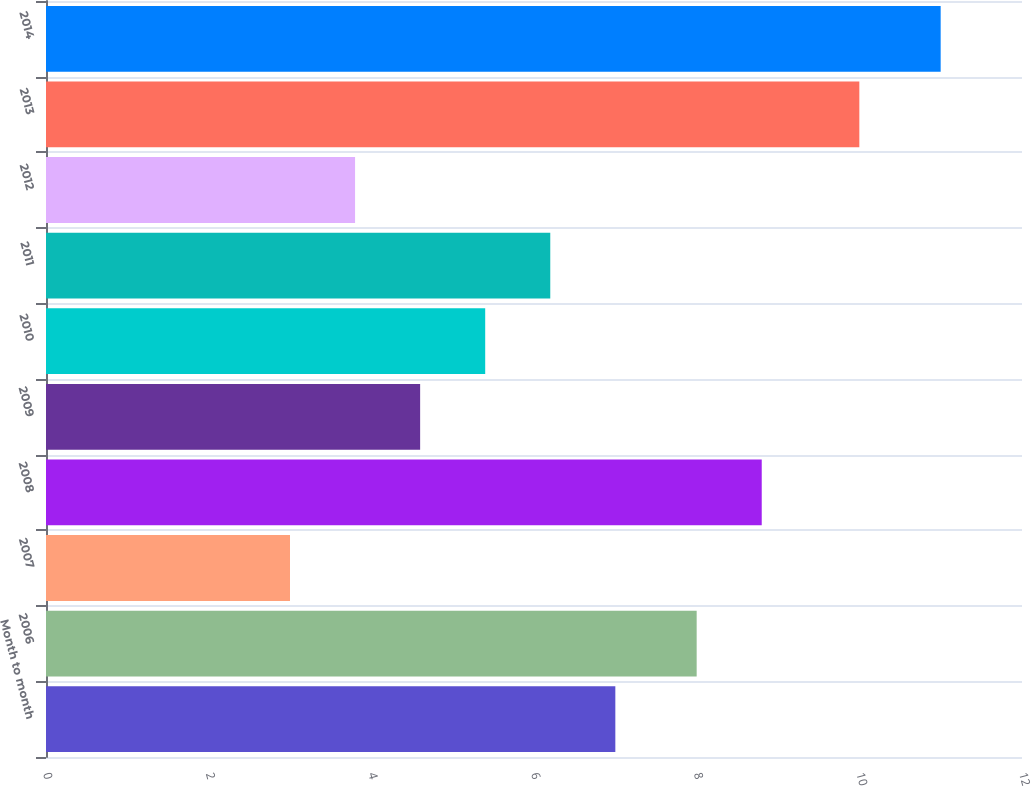<chart> <loc_0><loc_0><loc_500><loc_500><bar_chart><fcel>Month to month<fcel>2006<fcel>2007<fcel>2008<fcel>2009<fcel>2010<fcel>2011<fcel>2012<fcel>2013<fcel>2014<nl><fcel>7<fcel>8<fcel>3<fcel>8.8<fcel>4.6<fcel>5.4<fcel>6.2<fcel>3.8<fcel>10<fcel>11<nl></chart> 